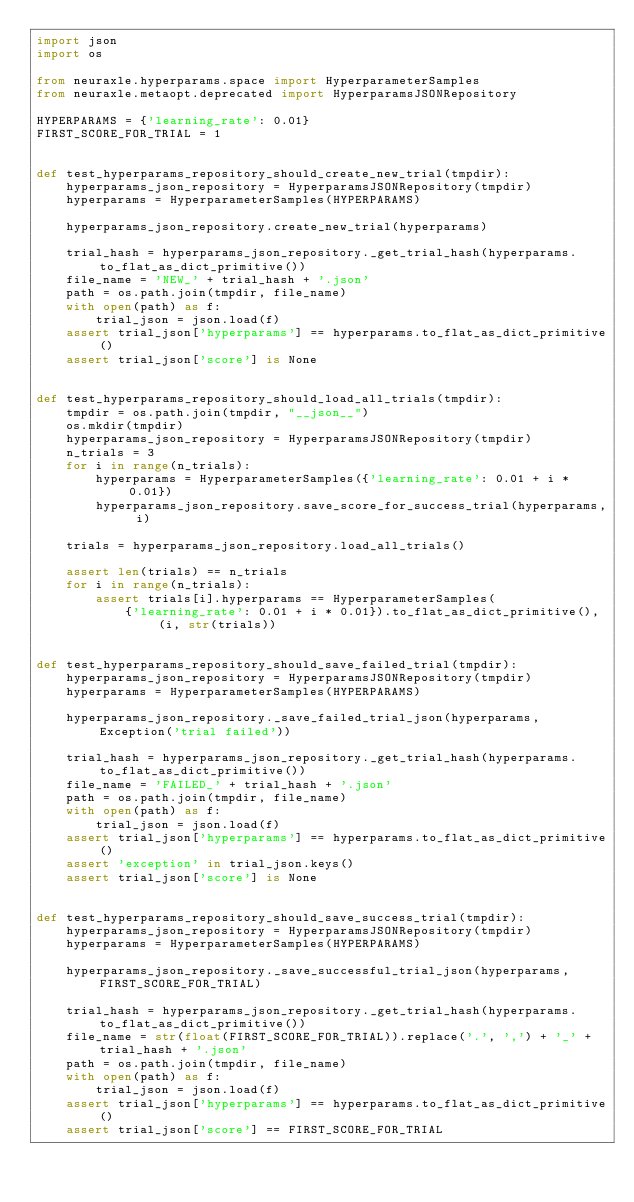<code> <loc_0><loc_0><loc_500><loc_500><_Python_>import json
import os

from neuraxle.hyperparams.space import HyperparameterSamples
from neuraxle.metaopt.deprecated import HyperparamsJSONRepository

HYPERPARAMS = {'learning_rate': 0.01}
FIRST_SCORE_FOR_TRIAL = 1


def test_hyperparams_repository_should_create_new_trial(tmpdir):
    hyperparams_json_repository = HyperparamsJSONRepository(tmpdir)
    hyperparams = HyperparameterSamples(HYPERPARAMS)

    hyperparams_json_repository.create_new_trial(hyperparams)

    trial_hash = hyperparams_json_repository._get_trial_hash(hyperparams.to_flat_as_dict_primitive())
    file_name = 'NEW_' + trial_hash + '.json'
    path = os.path.join(tmpdir, file_name)
    with open(path) as f:
        trial_json = json.load(f)
    assert trial_json['hyperparams'] == hyperparams.to_flat_as_dict_primitive()
    assert trial_json['score'] is None


def test_hyperparams_repository_should_load_all_trials(tmpdir):
    tmpdir = os.path.join(tmpdir, "__json__")
    os.mkdir(tmpdir)
    hyperparams_json_repository = HyperparamsJSONRepository(tmpdir)
    n_trials = 3
    for i in range(n_trials):
        hyperparams = HyperparameterSamples({'learning_rate': 0.01 + i * 0.01})
        hyperparams_json_repository.save_score_for_success_trial(hyperparams, i)

    trials = hyperparams_json_repository.load_all_trials()

    assert len(trials) == n_trials
    for i in range(n_trials):
        assert trials[i].hyperparams == HyperparameterSamples(
            {'learning_rate': 0.01 + i * 0.01}).to_flat_as_dict_primitive(), (i, str(trials))


def test_hyperparams_repository_should_save_failed_trial(tmpdir):
    hyperparams_json_repository = HyperparamsJSONRepository(tmpdir)
    hyperparams = HyperparameterSamples(HYPERPARAMS)

    hyperparams_json_repository._save_failed_trial_json(hyperparams, Exception('trial failed'))

    trial_hash = hyperparams_json_repository._get_trial_hash(hyperparams.to_flat_as_dict_primitive())
    file_name = 'FAILED_' + trial_hash + '.json'
    path = os.path.join(tmpdir, file_name)
    with open(path) as f:
        trial_json = json.load(f)
    assert trial_json['hyperparams'] == hyperparams.to_flat_as_dict_primitive()
    assert 'exception' in trial_json.keys()
    assert trial_json['score'] is None


def test_hyperparams_repository_should_save_success_trial(tmpdir):
    hyperparams_json_repository = HyperparamsJSONRepository(tmpdir)
    hyperparams = HyperparameterSamples(HYPERPARAMS)

    hyperparams_json_repository._save_successful_trial_json(hyperparams, FIRST_SCORE_FOR_TRIAL)

    trial_hash = hyperparams_json_repository._get_trial_hash(hyperparams.to_flat_as_dict_primitive())
    file_name = str(float(FIRST_SCORE_FOR_TRIAL)).replace('.', ',') + '_' + trial_hash + '.json'
    path = os.path.join(tmpdir, file_name)
    with open(path) as f:
        trial_json = json.load(f)
    assert trial_json['hyperparams'] == hyperparams.to_flat_as_dict_primitive()
    assert trial_json['score'] == FIRST_SCORE_FOR_TRIAL
</code> 